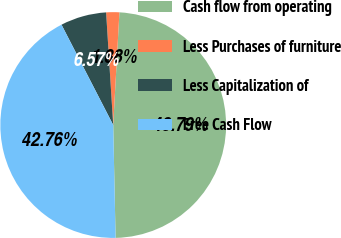<chart> <loc_0><loc_0><loc_500><loc_500><pie_chart><fcel>Cash flow from operating<fcel>Less Purchases of furniture<fcel>Less Capitalization of<fcel>Free Cash Flow<nl><fcel>48.79%<fcel>1.88%<fcel>6.57%<fcel>42.76%<nl></chart> 